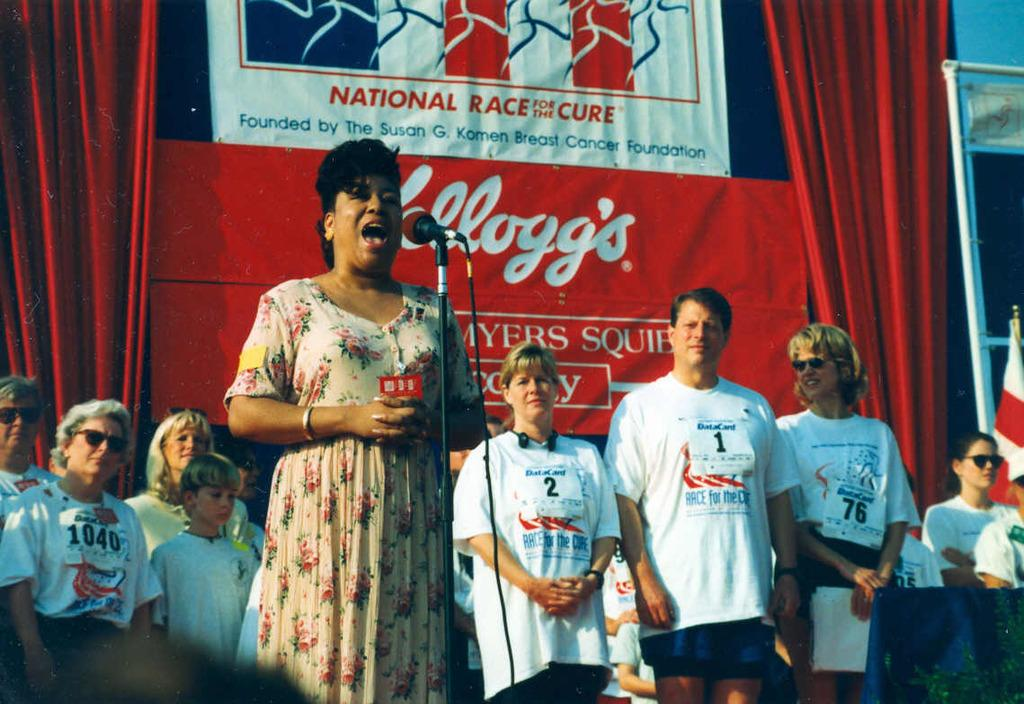<image>
Give a short and clear explanation of the subsequent image. woman sings while pople wearing race for the cure tshirts behind her 